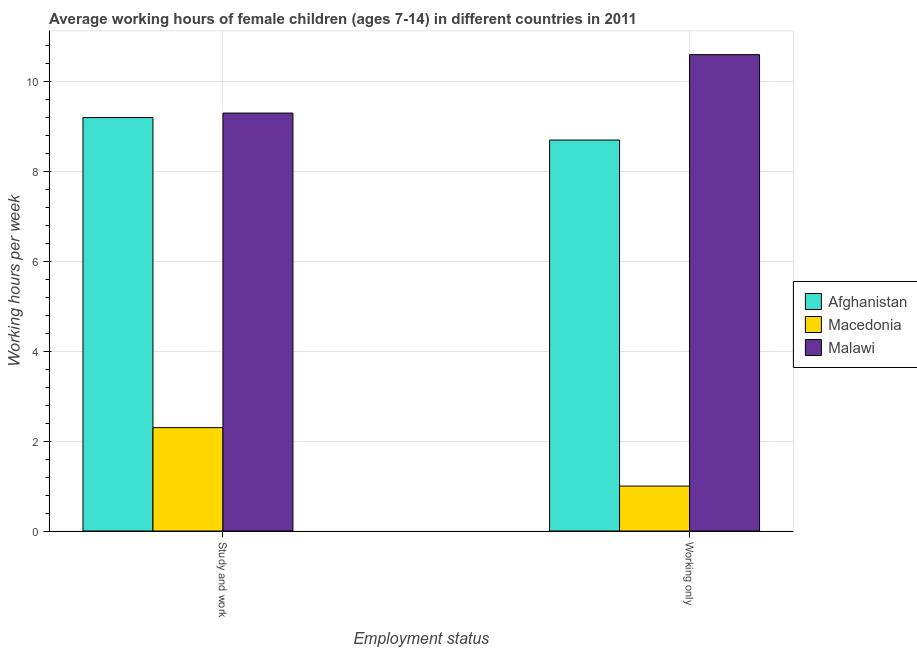How many different coloured bars are there?
Keep it short and to the point. 3. How many groups of bars are there?
Give a very brief answer. 2. Are the number of bars on each tick of the X-axis equal?
Provide a succinct answer. Yes. What is the label of the 2nd group of bars from the left?
Your response must be concise. Working only. What is the average working hour of children involved in study and work in Malawi?
Offer a terse response. 9.3. Across all countries, what is the minimum average working hour of children involved in only work?
Offer a very short reply. 1. In which country was the average working hour of children involved in only work maximum?
Your answer should be very brief. Malawi. In which country was the average working hour of children involved in study and work minimum?
Give a very brief answer. Macedonia. What is the total average working hour of children involved in study and work in the graph?
Your answer should be compact. 20.8. What is the difference between the average working hour of children involved in study and work in Malawi and the average working hour of children involved in only work in Macedonia?
Give a very brief answer. 8.3. What is the average average working hour of children involved in only work per country?
Make the answer very short. 6.77. What is the difference between the average working hour of children involved in only work and average working hour of children involved in study and work in Malawi?
Your answer should be very brief. 1.3. What is the ratio of the average working hour of children involved in study and work in Malawi to that in Afghanistan?
Your answer should be compact. 1.01. What does the 3rd bar from the left in Study and work represents?
Offer a terse response. Malawi. What does the 2nd bar from the right in Study and work represents?
Ensure brevity in your answer.  Macedonia. How many countries are there in the graph?
Ensure brevity in your answer.  3. Does the graph contain any zero values?
Provide a succinct answer. No. How many legend labels are there?
Offer a very short reply. 3. How are the legend labels stacked?
Your response must be concise. Vertical. What is the title of the graph?
Offer a terse response. Average working hours of female children (ages 7-14) in different countries in 2011. What is the label or title of the X-axis?
Your response must be concise. Employment status. What is the label or title of the Y-axis?
Offer a terse response. Working hours per week. What is the Working hours per week in Malawi in Study and work?
Your answer should be very brief. 9.3. What is the Working hours per week of Afghanistan in Working only?
Provide a short and direct response. 8.7. Across all Employment status, what is the maximum Working hours per week in Afghanistan?
Provide a succinct answer. 9.2. Across all Employment status, what is the minimum Working hours per week in Malawi?
Provide a short and direct response. 9.3. What is the total Working hours per week of Macedonia in the graph?
Your response must be concise. 3.3. What is the difference between the Working hours per week of Afghanistan in Study and work and that in Working only?
Provide a succinct answer. 0.5. What is the difference between the Working hours per week in Malawi in Study and work and that in Working only?
Provide a short and direct response. -1.3. What is the difference between the Working hours per week in Afghanistan in Study and work and the Working hours per week in Malawi in Working only?
Offer a terse response. -1.4. What is the average Working hours per week of Afghanistan per Employment status?
Keep it short and to the point. 8.95. What is the average Working hours per week of Macedonia per Employment status?
Make the answer very short. 1.65. What is the average Working hours per week in Malawi per Employment status?
Offer a terse response. 9.95. What is the difference between the Working hours per week in Afghanistan and Working hours per week in Macedonia in Study and work?
Offer a terse response. 6.9. What is the difference between the Working hours per week of Macedonia and Working hours per week of Malawi in Study and work?
Provide a succinct answer. -7. What is the difference between the Working hours per week of Afghanistan and Working hours per week of Malawi in Working only?
Make the answer very short. -1.9. What is the ratio of the Working hours per week of Afghanistan in Study and work to that in Working only?
Offer a terse response. 1.06. What is the ratio of the Working hours per week in Macedonia in Study and work to that in Working only?
Keep it short and to the point. 2.3. What is the ratio of the Working hours per week of Malawi in Study and work to that in Working only?
Provide a succinct answer. 0.88. What is the difference between the highest and the second highest Working hours per week in Macedonia?
Your answer should be very brief. 1.3. What is the difference between the highest and the lowest Working hours per week of Macedonia?
Give a very brief answer. 1.3. What is the difference between the highest and the lowest Working hours per week of Malawi?
Your answer should be compact. 1.3. 